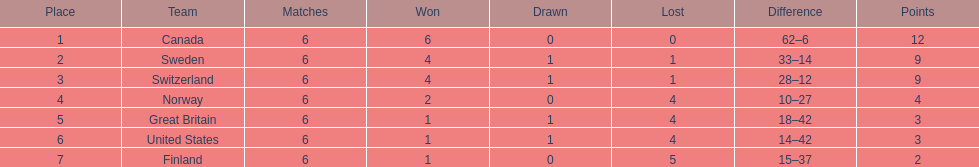In how many instances did teams secure at least four match wins? 3. 